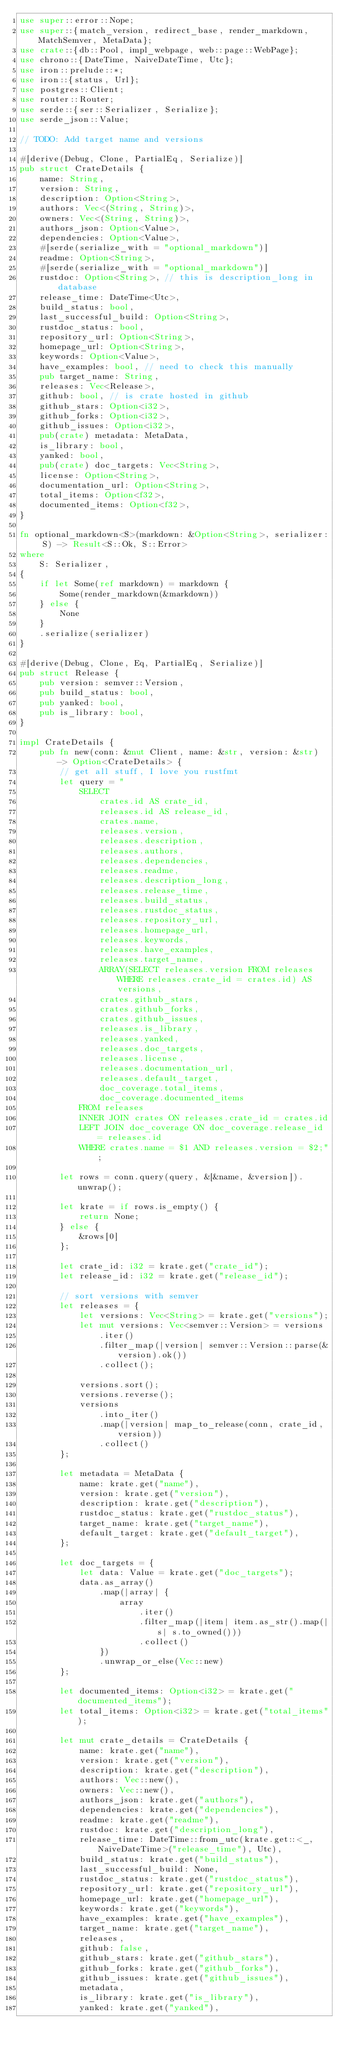<code> <loc_0><loc_0><loc_500><loc_500><_Rust_>use super::error::Nope;
use super::{match_version, redirect_base, render_markdown, MatchSemver, MetaData};
use crate::{db::Pool, impl_webpage, web::page::WebPage};
use chrono::{DateTime, NaiveDateTime, Utc};
use iron::prelude::*;
use iron::{status, Url};
use postgres::Client;
use router::Router;
use serde::{ser::Serializer, Serialize};
use serde_json::Value;

// TODO: Add target name and versions

#[derive(Debug, Clone, PartialEq, Serialize)]
pub struct CrateDetails {
    name: String,
    version: String,
    description: Option<String>,
    authors: Vec<(String, String)>,
    owners: Vec<(String, String)>,
    authors_json: Option<Value>,
    dependencies: Option<Value>,
    #[serde(serialize_with = "optional_markdown")]
    readme: Option<String>,
    #[serde(serialize_with = "optional_markdown")]
    rustdoc: Option<String>, // this is description_long in database
    release_time: DateTime<Utc>,
    build_status: bool,
    last_successful_build: Option<String>,
    rustdoc_status: bool,
    repository_url: Option<String>,
    homepage_url: Option<String>,
    keywords: Option<Value>,
    have_examples: bool, // need to check this manually
    pub target_name: String,
    releases: Vec<Release>,
    github: bool, // is crate hosted in github
    github_stars: Option<i32>,
    github_forks: Option<i32>,
    github_issues: Option<i32>,
    pub(crate) metadata: MetaData,
    is_library: bool,
    yanked: bool,
    pub(crate) doc_targets: Vec<String>,
    license: Option<String>,
    documentation_url: Option<String>,
    total_items: Option<f32>,
    documented_items: Option<f32>,
}

fn optional_markdown<S>(markdown: &Option<String>, serializer: S) -> Result<S::Ok, S::Error>
where
    S: Serializer,
{
    if let Some(ref markdown) = markdown {
        Some(render_markdown(&markdown))
    } else {
        None
    }
    .serialize(serializer)
}

#[derive(Debug, Clone, Eq, PartialEq, Serialize)]
pub struct Release {
    pub version: semver::Version,
    pub build_status: bool,
    pub yanked: bool,
    pub is_library: bool,
}

impl CrateDetails {
    pub fn new(conn: &mut Client, name: &str, version: &str) -> Option<CrateDetails> {
        // get all stuff, I love you rustfmt
        let query = "
            SELECT
                crates.id AS crate_id,
                releases.id AS release_id,
                crates.name,
                releases.version,
                releases.description,
                releases.authors,
                releases.dependencies,
                releases.readme,
                releases.description_long,
                releases.release_time,
                releases.build_status,
                releases.rustdoc_status,
                releases.repository_url,
                releases.homepage_url,
                releases.keywords,
                releases.have_examples,
                releases.target_name,
                ARRAY(SELECT releases.version FROM releases WHERE releases.crate_id = crates.id) AS versions,
                crates.github_stars,
                crates.github_forks,
                crates.github_issues,
                releases.is_library,
                releases.yanked,
                releases.doc_targets,
                releases.license,
                releases.documentation_url,
                releases.default_target,
                doc_coverage.total_items,
                doc_coverage.documented_items
            FROM releases
            INNER JOIN crates ON releases.crate_id = crates.id
            LEFT JOIN doc_coverage ON doc_coverage.release_id = releases.id
            WHERE crates.name = $1 AND releases.version = $2;";

        let rows = conn.query(query, &[&name, &version]).unwrap();

        let krate = if rows.is_empty() {
            return None;
        } else {
            &rows[0]
        };

        let crate_id: i32 = krate.get("crate_id");
        let release_id: i32 = krate.get("release_id");

        // sort versions with semver
        let releases = {
            let versions: Vec<String> = krate.get("versions");
            let mut versions: Vec<semver::Version> = versions
                .iter()
                .filter_map(|version| semver::Version::parse(&version).ok())
                .collect();

            versions.sort();
            versions.reverse();
            versions
                .into_iter()
                .map(|version| map_to_release(conn, crate_id, version))
                .collect()
        };

        let metadata = MetaData {
            name: krate.get("name"),
            version: krate.get("version"),
            description: krate.get("description"),
            rustdoc_status: krate.get("rustdoc_status"),
            target_name: krate.get("target_name"),
            default_target: krate.get("default_target"),
        };

        let doc_targets = {
            let data: Value = krate.get("doc_targets");
            data.as_array()
                .map(|array| {
                    array
                        .iter()
                        .filter_map(|item| item.as_str().map(|s| s.to_owned()))
                        .collect()
                })
                .unwrap_or_else(Vec::new)
        };

        let documented_items: Option<i32> = krate.get("documented_items");
        let total_items: Option<i32> = krate.get("total_items");

        let mut crate_details = CrateDetails {
            name: krate.get("name"),
            version: krate.get("version"),
            description: krate.get("description"),
            authors: Vec::new(),
            owners: Vec::new(),
            authors_json: krate.get("authors"),
            dependencies: krate.get("dependencies"),
            readme: krate.get("readme"),
            rustdoc: krate.get("description_long"),
            release_time: DateTime::from_utc(krate.get::<_, NaiveDateTime>("release_time"), Utc),
            build_status: krate.get("build_status"),
            last_successful_build: None,
            rustdoc_status: krate.get("rustdoc_status"),
            repository_url: krate.get("repository_url"),
            homepage_url: krate.get("homepage_url"),
            keywords: krate.get("keywords"),
            have_examples: krate.get("have_examples"),
            target_name: krate.get("target_name"),
            releases,
            github: false,
            github_stars: krate.get("github_stars"),
            github_forks: krate.get("github_forks"),
            github_issues: krate.get("github_issues"),
            metadata,
            is_library: krate.get("is_library"),
            yanked: krate.get("yanked"),</code> 